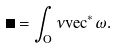<formula> <loc_0><loc_0><loc_500><loc_500>\Omega = \int _ { O } \nu v e c ^ { * } \omega .</formula> 